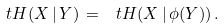Convert formula to latex. <formula><loc_0><loc_0><loc_500><loc_500>\ t H ( X \, | \, Y ) \, = \, \ t H ( X \, | \, \phi ( Y ) ) \, .</formula> 